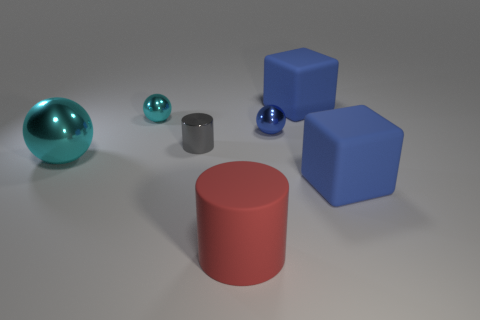Is there a gray metallic object that has the same size as the gray shiny cylinder?
Make the answer very short. No. Do the large rubber cube that is behind the big cyan metal object and the large sphere have the same color?
Keep it short and to the point. No. The big object that is behind the rubber cylinder and to the left of the blue sphere is what color?
Ensure brevity in your answer.  Cyan. What shape is the cyan metal object that is the same size as the gray metal cylinder?
Offer a terse response. Sphere. Is there a big cyan metallic object that has the same shape as the gray thing?
Your answer should be compact. No. Is the size of the shiny object that is to the right of the red matte cylinder the same as the big red matte thing?
Make the answer very short. No. There is a object that is both behind the small gray cylinder and to the right of the blue shiny object; what is its size?
Your answer should be compact. Large. What number of other things are there of the same material as the gray thing
Keep it short and to the point. 3. How big is the ball to the right of the red rubber cylinder?
Your response must be concise. Small. Do the tiny cylinder and the matte cylinder have the same color?
Provide a succinct answer. No. 